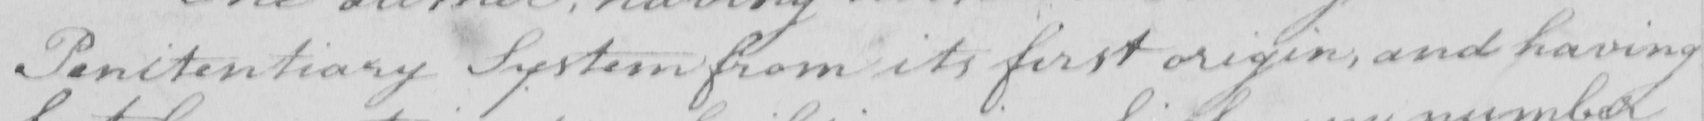Please transcribe the handwritten text in this image. Penitentiary System from its first origin , and having 